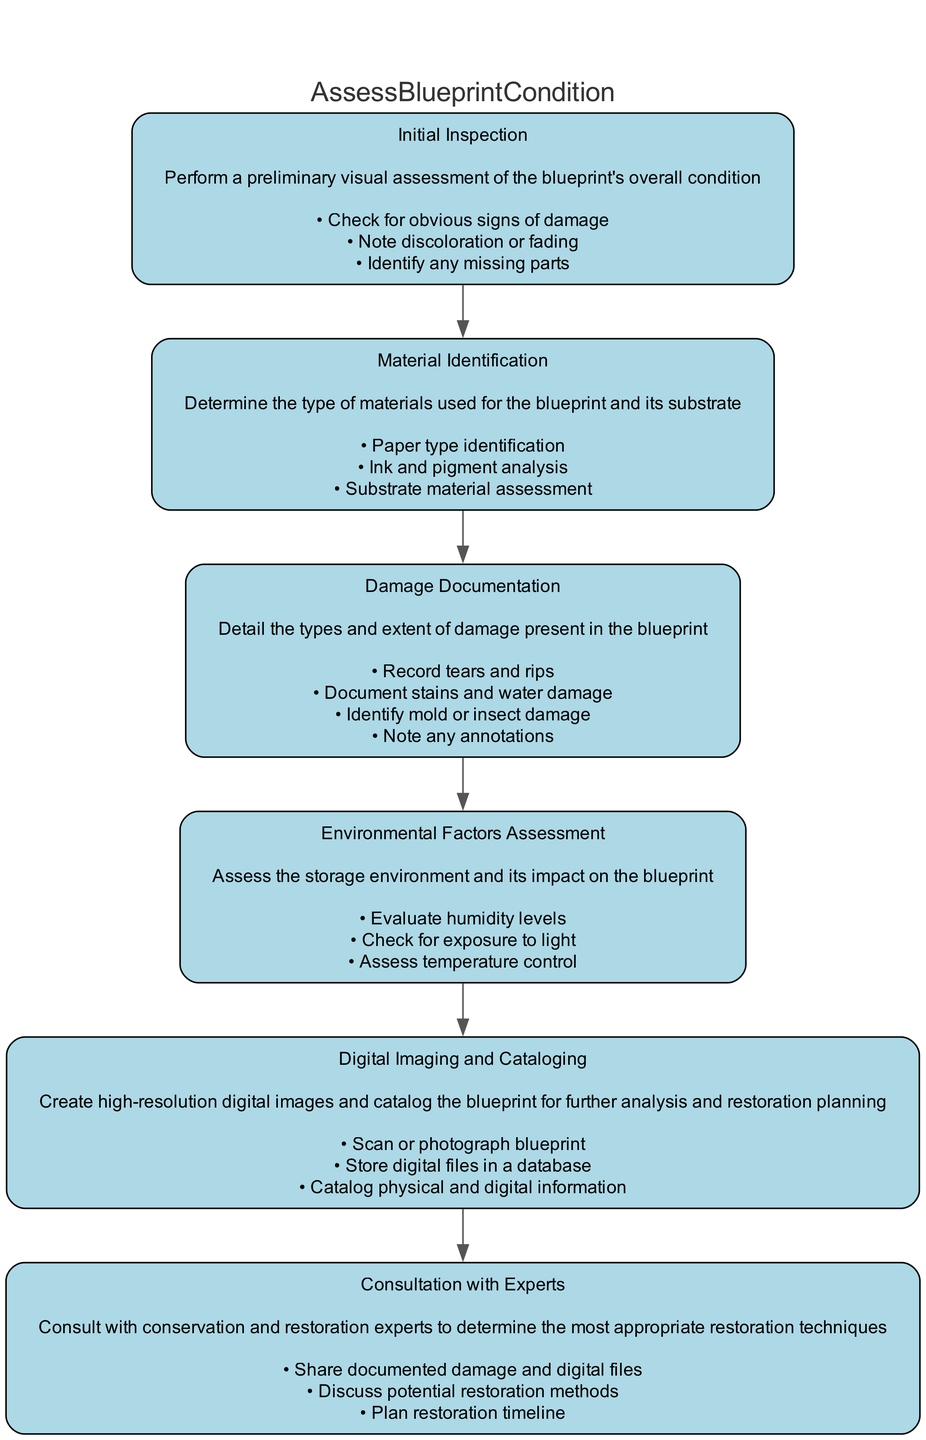What is the first step in the diagram? The first step in the flowchart is labeled "Initial Inspection," indicating that it is the starting point of assessing the blueprint's condition.
Answer: Initial Inspection How many total steps are included in the assessment process? By counting the nodes in the flowchart, we find there are 6 steps involved in assessing the condition of physical blueprints.
Answer: 6 What is the last action performed in the flowchart? The last action is listed under "Consultation with Experts," which signifies that consulting experts is the final part of the assessment process.
Answer: Consult with Experts Which step involves evaluating humidity levels? The step that involves evaluating humidity levels is "Environmental Factors Assessment," indicating that this is where environmental impacts on the blueprint are assessed.
Answer: Environmental Factors Assessment What actions are included in the "Damage Documentation" step? In the "Damage Documentation" step, the actions listed include recording tears and rips, documenting stains and water damage, identifying mold or insect damage, and noting any annotations, which detail the damage present in the blueprint.
Answer: Record tears and rips, Document stains and water damage, Identify mold or insect damage, Note any annotations What is the main function of the flowchart? The main function of the flowchart is to assess the condition of physical blueprints for restoration, guiding users through a structured process to evaluate blueprints effectively.
Answer: Assess Blueprint Condition 